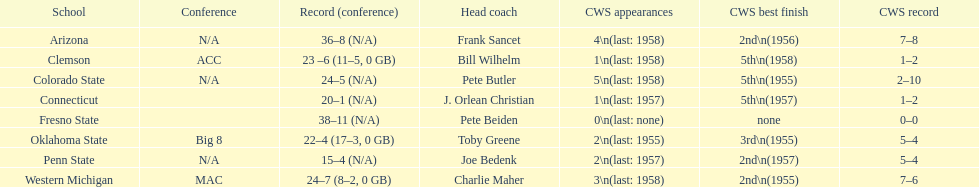Which team did not surpass a total of 16 wins? Penn State. 